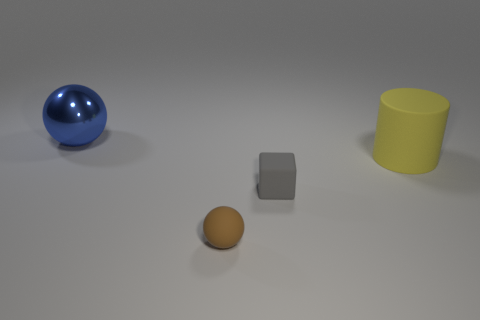What size is the shiny thing?
Offer a terse response. Large. There is a brown ball that is the same size as the rubber block; what is its material?
Your answer should be compact. Rubber. What color is the ball in front of the large matte object?
Make the answer very short. Brown. What number of yellow spheres are there?
Your answer should be very brief. 0. Is there a large cylinder that is in front of the tiny brown rubber ball that is in front of the rubber block that is in front of the large cylinder?
Ensure brevity in your answer.  No. What is the shape of the gray rubber thing that is the same size as the brown object?
Give a very brief answer. Cube. What is the big sphere made of?
Offer a very short reply. Metal. How many other things are made of the same material as the large yellow cylinder?
Ensure brevity in your answer.  2. There is a thing that is both behind the gray rubber thing and on the left side of the small gray block; how big is it?
Give a very brief answer. Large. There is a big object that is on the right side of the large object that is to the left of the cylinder; what shape is it?
Your answer should be compact. Cylinder. 